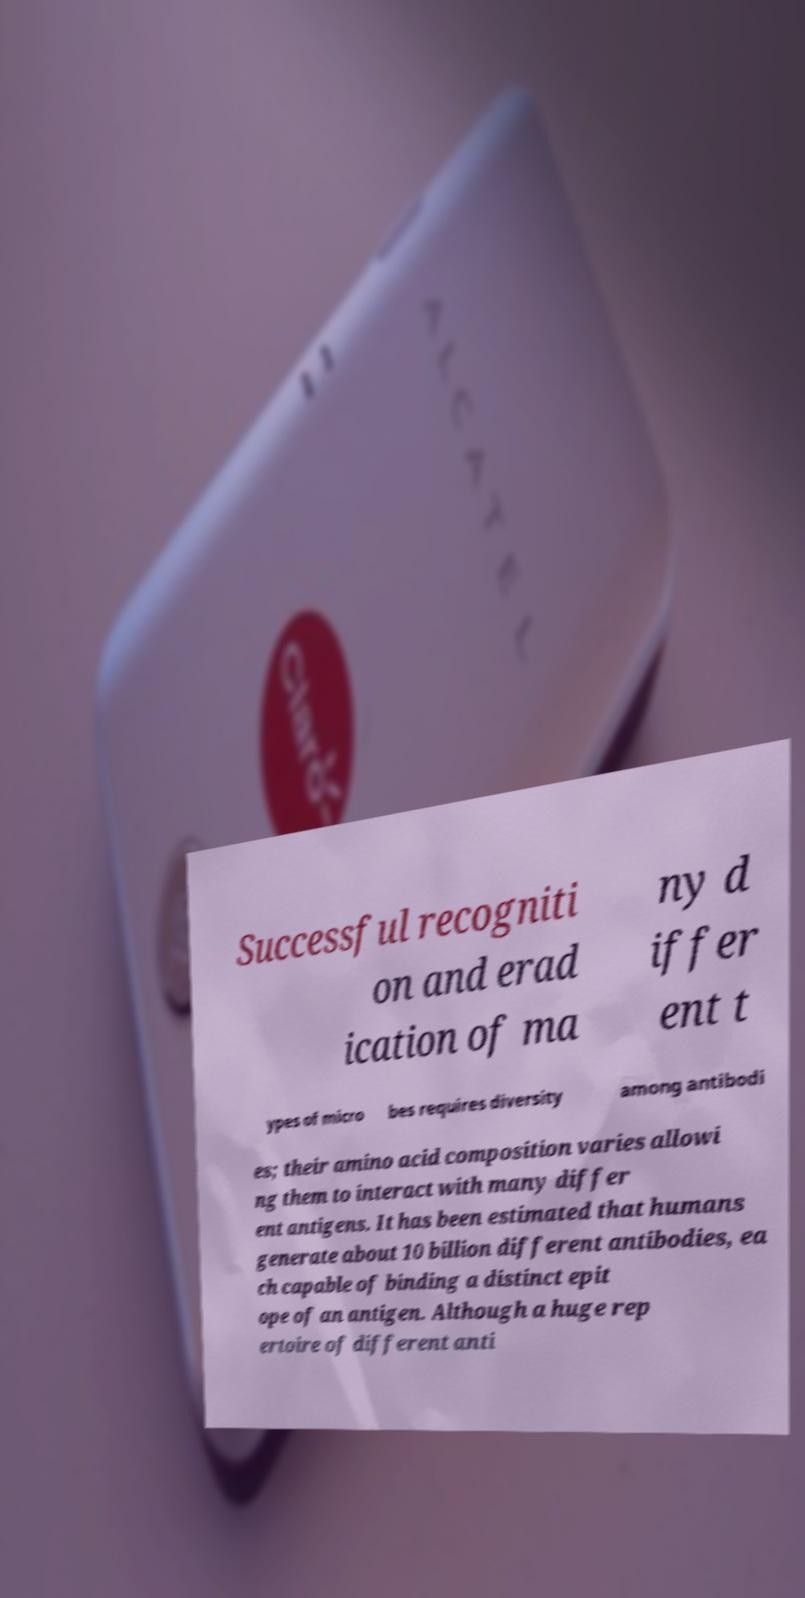Can you read and provide the text displayed in the image?This photo seems to have some interesting text. Can you extract and type it out for me? Successful recogniti on and erad ication of ma ny d iffer ent t ypes of micro bes requires diversity among antibodi es; their amino acid composition varies allowi ng them to interact with many differ ent antigens. It has been estimated that humans generate about 10 billion different antibodies, ea ch capable of binding a distinct epit ope of an antigen. Although a huge rep ertoire of different anti 